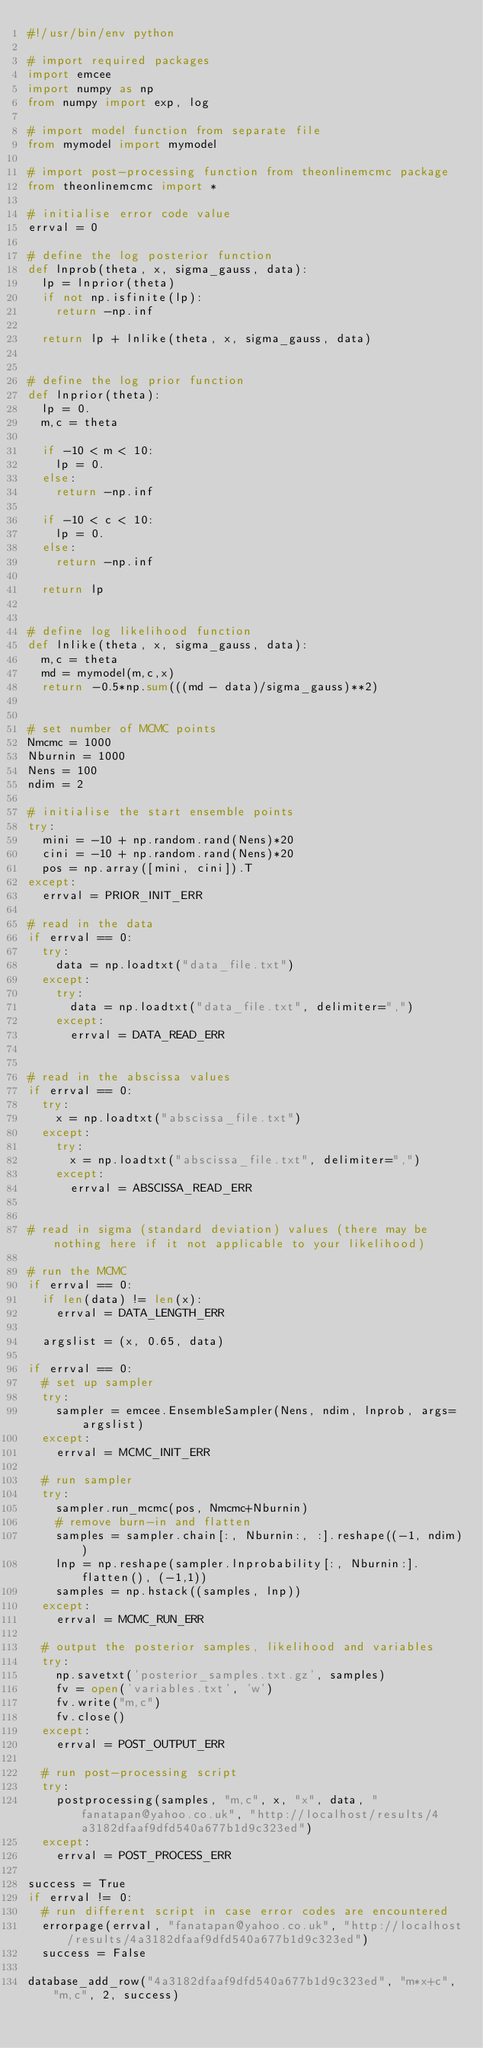Convert code to text. <code><loc_0><loc_0><loc_500><loc_500><_Python_>#!/usr/bin/env python

# import required packages
import emcee
import numpy as np
from numpy import exp, log

# import model function from separate file
from mymodel import mymodel

# import post-processing function from theonlinemcmc package
from theonlinemcmc import *

# initialise error code value
errval = 0

# define the log posterior function
def lnprob(theta, x, sigma_gauss, data):
  lp = lnprior(theta)
  if not np.isfinite(lp):
    return -np.inf

  return lp + lnlike(theta, x, sigma_gauss, data)


# define the log prior function
def lnprior(theta):
  lp = 0.
  m,c = theta

  if -10 < m < 10:
    lp = 0.
  else:
    return -np.inf

  if -10 < c < 10:
    lp = 0.
  else:
    return -np.inf

  return lp


# define log likelihood function
def lnlike(theta, x, sigma_gauss, data):
  m,c = theta
  md = mymodel(m,c,x)
  return -0.5*np.sum(((md - data)/sigma_gauss)**2)


# set number of MCMC points
Nmcmc = 1000
Nburnin = 1000
Nens = 100
ndim = 2

# initialise the start ensemble points
try:
  mini = -10 + np.random.rand(Nens)*20
  cini = -10 + np.random.rand(Nens)*20
  pos = np.array([mini, cini]).T
except:
  errval = PRIOR_INIT_ERR

# read in the data
if errval == 0:
  try:
    data = np.loadtxt("data_file.txt")
  except:
    try:
      data = np.loadtxt("data_file.txt", delimiter=",")
    except:
      errval = DATA_READ_ERR


# read in the abscissa values
if errval == 0:
  try:
    x = np.loadtxt("abscissa_file.txt")
  except:
    try:
      x = np.loadtxt("abscissa_file.txt", delimiter=",")
    except:
      errval = ABSCISSA_READ_ERR


# read in sigma (standard deviation) values (there may be nothing here if it not applicable to your likelihood)

# run the MCMC
if errval == 0:
  if len(data) != len(x):
    errval = DATA_LENGTH_ERR

  argslist = (x, 0.65, data)

if errval == 0:
  # set up sampler
  try:
    sampler = emcee.EnsembleSampler(Nens, ndim, lnprob, args=argslist)
  except:
    errval = MCMC_INIT_ERR

  # run sampler
  try:
    sampler.run_mcmc(pos, Nmcmc+Nburnin)
    # remove burn-in and flatten
    samples = sampler.chain[:, Nburnin:, :].reshape((-1, ndim))
    lnp = np.reshape(sampler.lnprobability[:, Nburnin:].flatten(), (-1,1))
    samples = np.hstack((samples, lnp))
  except:
    errval = MCMC_RUN_ERR

  # output the posterior samples, likelihood and variables
  try:
    np.savetxt('posterior_samples.txt.gz', samples)
    fv = open('variables.txt', 'w')
    fv.write("m,c")
    fv.close()
  except:
    errval = POST_OUTPUT_ERR

  # run post-processing script
  try:
    postprocessing(samples, "m,c", x, "x", data, "fanatapan@yahoo.co.uk", "http://localhost/results/4a3182dfaaf9dfd540a677b1d9c323ed")
  except:
    errval = POST_PROCESS_ERR

success = True
if errval != 0:
  # run different script in case error codes are encountered
  errorpage(errval, "fanatapan@yahoo.co.uk", "http://localhost/results/4a3182dfaaf9dfd540a677b1d9c323ed")
  success = False

database_add_row("4a3182dfaaf9dfd540a677b1d9c323ed", "m*x+c", "m,c", 2, success)


</code> 